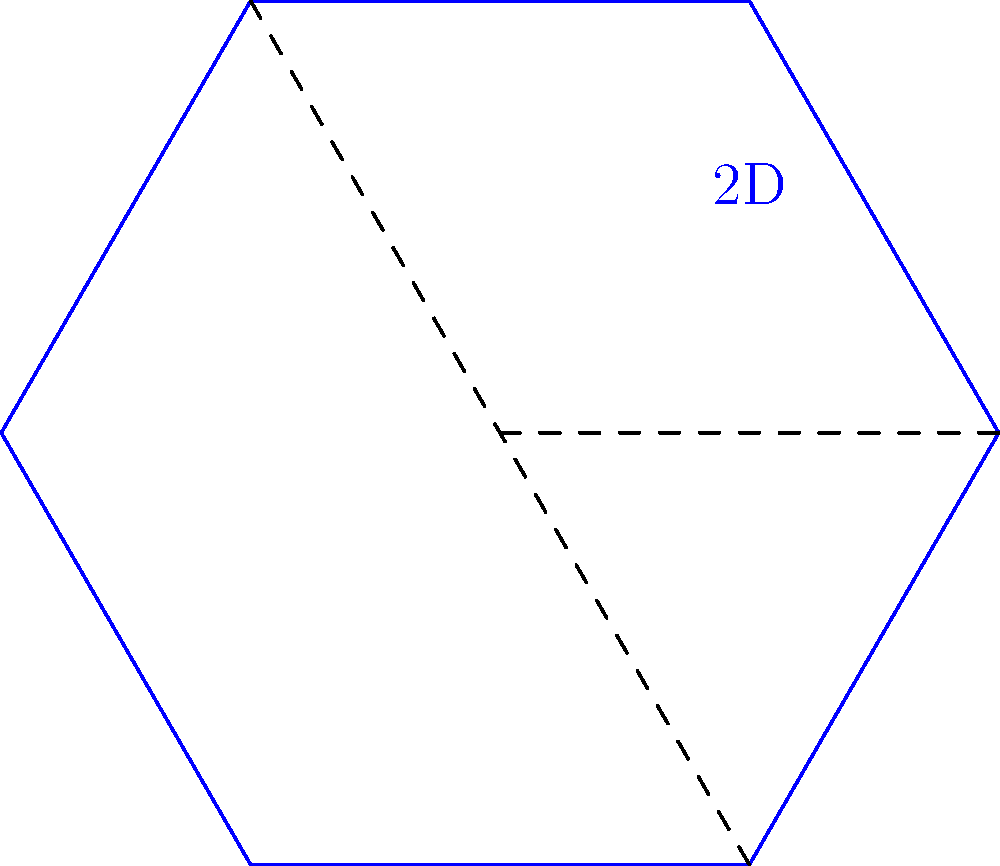In your new career, you're tasked with designing packaging for a product. You're given a flat hexagonal sheet of material. If you fold this sheet along two parallel sides to create a three-dimensional shape, what type of object will you form? To solve this problem, let's follow these steps:

1. Visualize the initial 2D shape:
   - We start with a flat hexagonal sheet.

2. Identify the folding lines:
   - The question states we fold along two parallel sides.
   - In a hexagon, opposite sides are always parallel.

3. Imagine the folding process:
   - As we fold two parallel sides towards each other, the other four sides will form the lateral faces of the 3D shape.
   - The two parallel sides that we're folding will form the top and bottom of the 3D shape.

4. Analyze the resulting 3D shape:
   - The top and bottom are hexagons (unchanged from the original shape).
   - The lateral faces are rectangles, formed by the other four sides of the hexagon and the height of the fold.

5. Identify the 3D object:
   - A 3D shape with two parallel hexagonal bases and rectangular lateral faces is called a hexagonal prism.

Therefore, folding the flat hexagonal sheet along two parallel sides will result in forming a hexagonal prism.
Answer: Hexagonal prism 